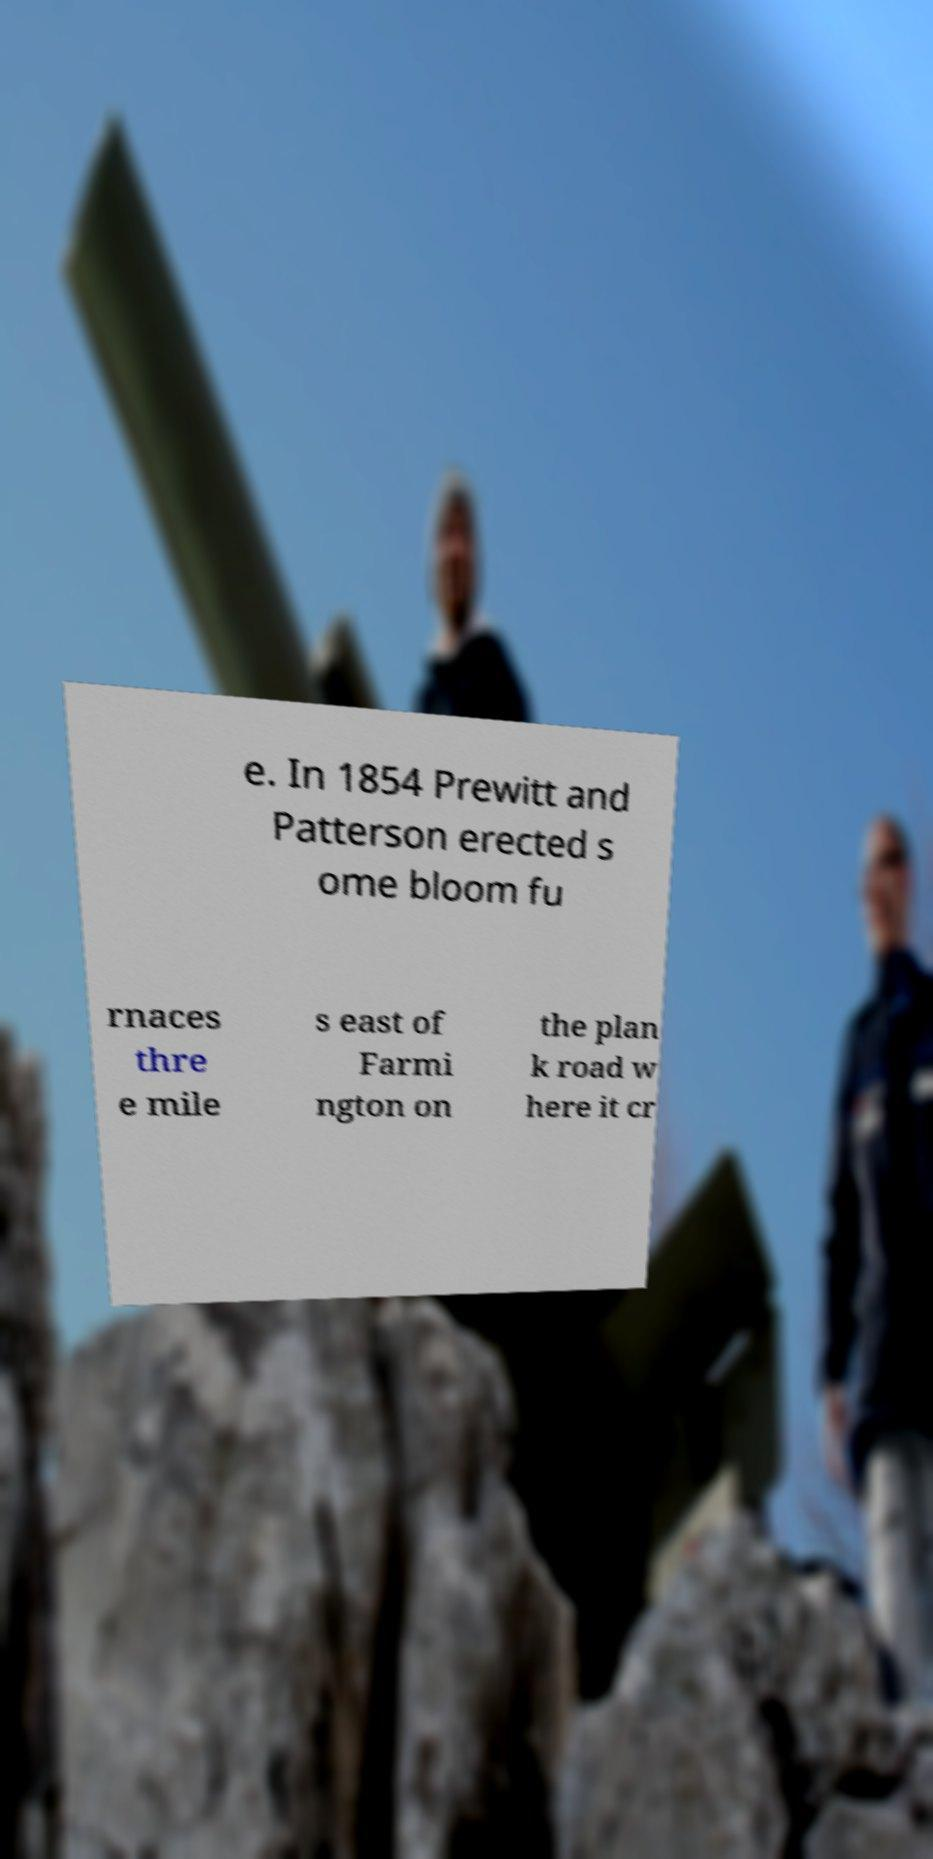Can you accurately transcribe the text from the provided image for me? e. In 1854 Prewitt and Patterson erected s ome bloom fu rnaces thre e mile s east of Farmi ngton on the plan k road w here it cr 